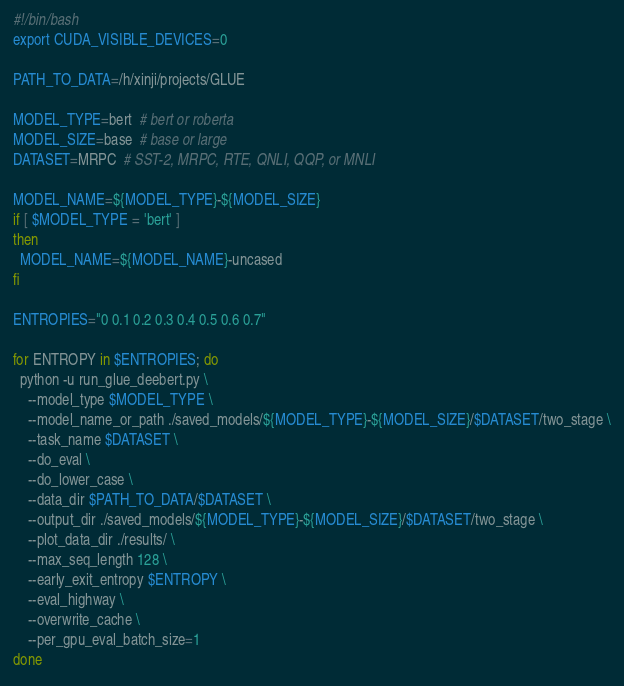Convert code to text. <code><loc_0><loc_0><loc_500><loc_500><_Bash_>#!/bin/bash
export CUDA_VISIBLE_DEVICES=0

PATH_TO_DATA=/h/xinji/projects/GLUE

MODEL_TYPE=bert  # bert or roberta
MODEL_SIZE=base  # base or large
DATASET=MRPC  # SST-2, MRPC, RTE, QNLI, QQP, or MNLI

MODEL_NAME=${MODEL_TYPE}-${MODEL_SIZE}
if [ $MODEL_TYPE = 'bert' ]
then
  MODEL_NAME=${MODEL_NAME}-uncased
fi

ENTROPIES="0 0.1 0.2 0.3 0.4 0.5 0.6 0.7"

for ENTROPY in $ENTROPIES; do
  python -u run_glue_deebert.py \
    --model_type $MODEL_TYPE \
    --model_name_or_path ./saved_models/${MODEL_TYPE}-${MODEL_SIZE}/$DATASET/two_stage \
    --task_name $DATASET \
    --do_eval \
    --do_lower_case \
    --data_dir $PATH_TO_DATA/$DATASET \
    --output_dir ./saved_models/${MODEL_TYPE}-${MODEL_SIZE}/$DATASET/two_stage \
    --plot_data_dir ./results/ \
    --max_seq_length 128 \
    --early_exit_entropy $ENTROPY \
    --eval_highway \
    --overwrite_cache \
    --per_gpu_eval_batch_size=1
done
</code> 